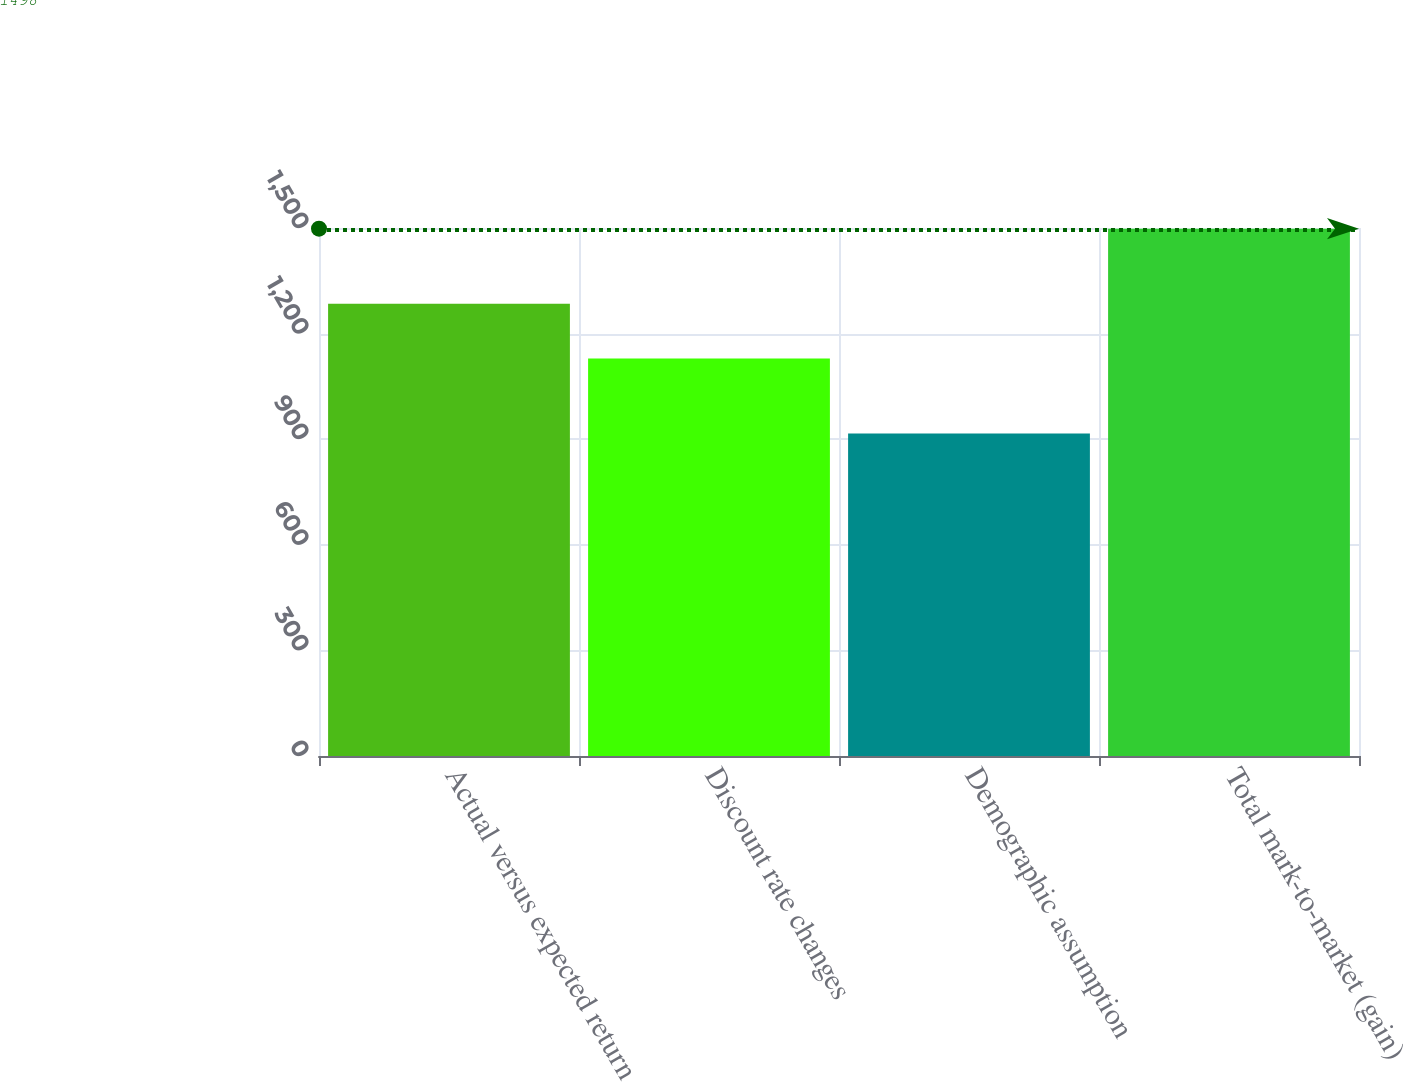<chart> <loc_0><loc_0><loc_500><loc_500><bar_chart><fcel>Actual versus expected return<fcel>Discount rate changes<fcel>Demographic assumption<fcel>Total mark-to-market (gain)<nl><fcel>1285<fcel>1129<fcel>916<fcel>1498<nl></chart> 